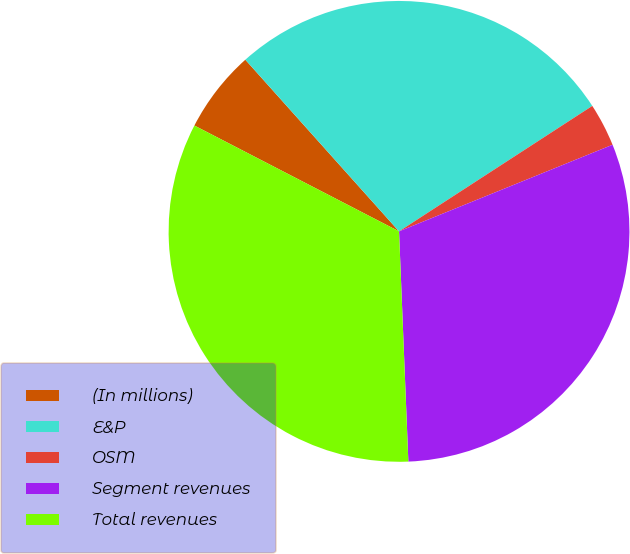Convert chart. <chart><loc_0><loc_0><loc_500><loc_500><pie_chart><fcel>(In millions)<fcel>E&P<fcel>OSM<fcel>Segment revenues<fcel>Total revenues<nl><fcel>5.78%<fcel>27.46%<fcel>3.03%<fcel>30.49%<fcel>33.24%<nl></chart> 